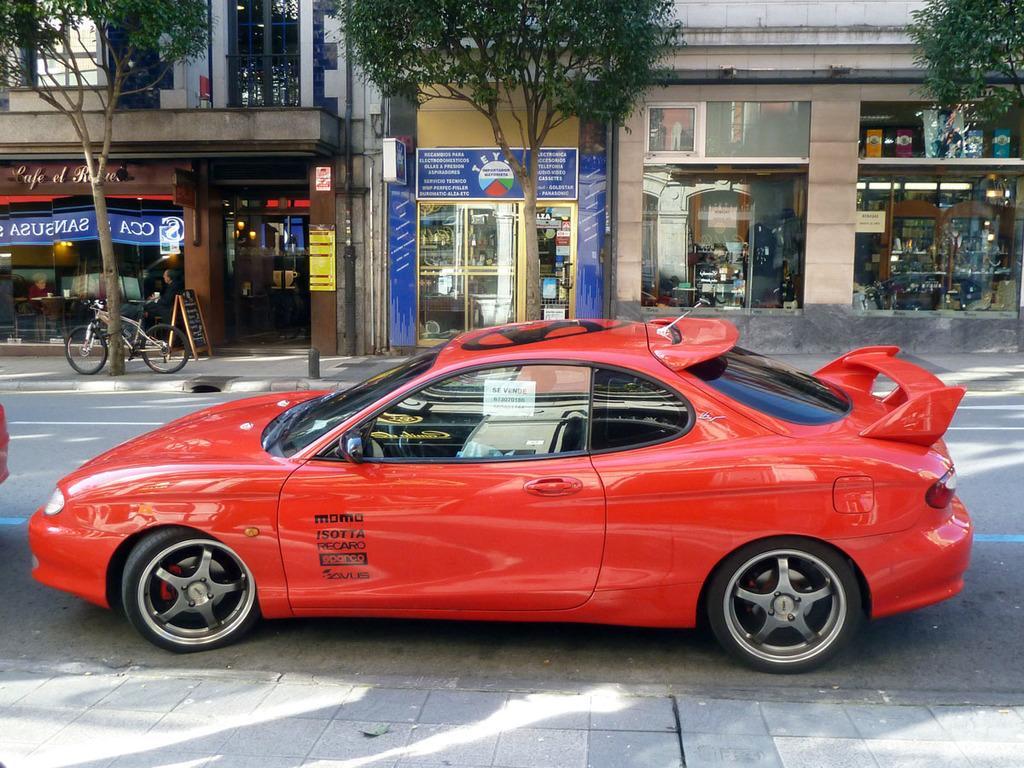Can you describe this image briefly? In this image, we can see a red car, we can see the road, there are some shops and we can see some trees, there is a bicycle. 